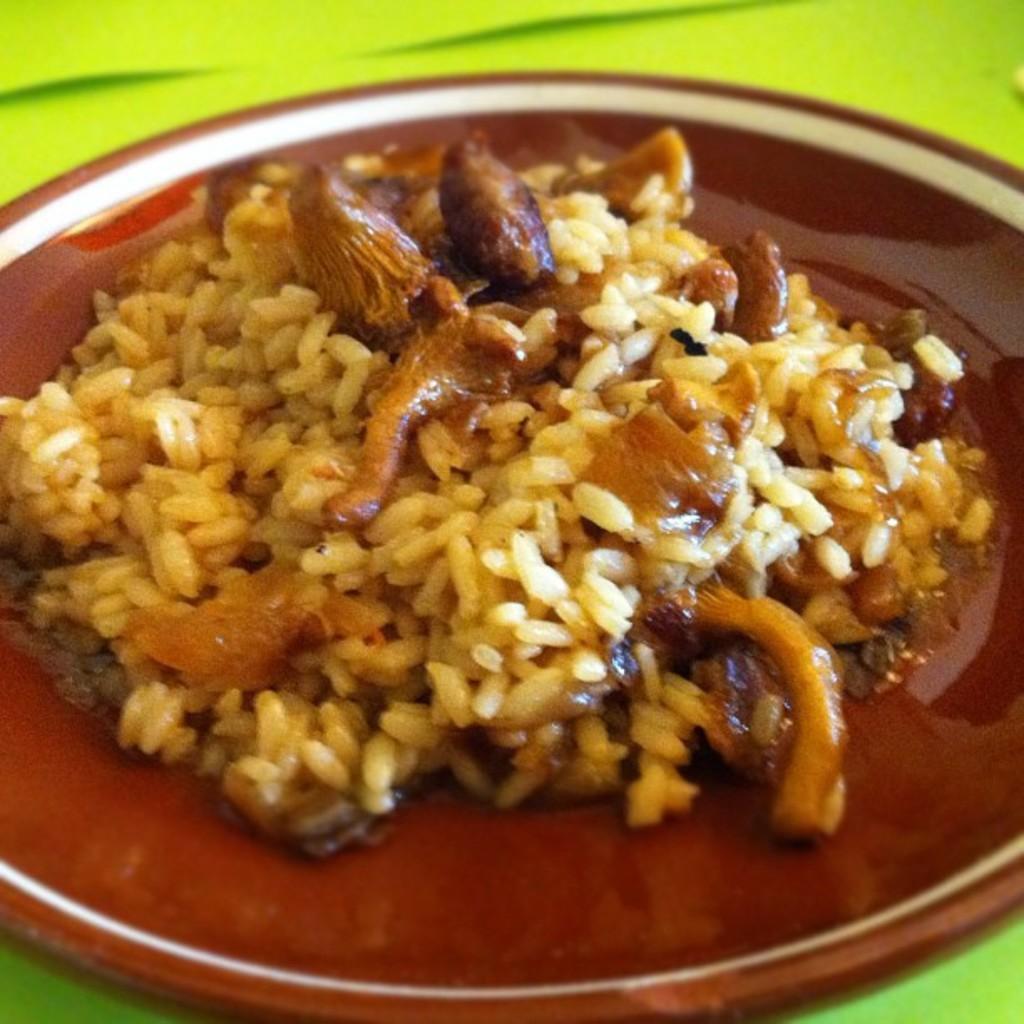Could you give a brief overview of what you see in this image? This image consists of food items in a plate kept on the table. This image is taken may be in a room. 